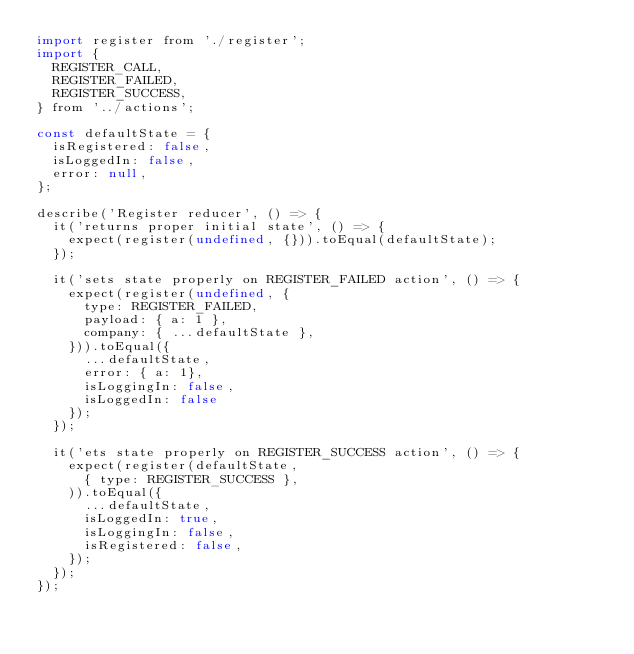<code> <loc_0><loc_0><loc_500><loc_500><_JavaScript_>import register from './register';
import {
  REGISTER_CALL,
  REGISTER_FAILED,
  REGISTER_SUCCESS,
} from '../actions';

const defaultState = {
  isRegistered: false,
  isLoggedIn: false,
  error: null,
};

describe('Register reducer', () => {
  it('returns proper initial state', () => {
    expect(register(undefined, {})).toEqual(defaultState);
  });

  it('sets state properly on REGISTER_FAILED action', () => {
    expect(register(undefined, {
      type: REGISTER_FAILED,
      payload: { a: 1 },
      company: { ...defaultState },
    })).toEqual({
      ...defaultState,
      error: { a: 1},
      isLoggingIn: false,
      isLoggedIn: false
    });
  });

  it('ets state properly on REGISTER_SUCCESS action', () => {
    expect(register(defaultState,
      { type: REGISTER_SUCCESS },
    )).toEqual({
      ...defaultState,
      isLoggedIn: true,
      isLoggingIn: false,
      isRegistered: false,
    });
  });
});
</code> 